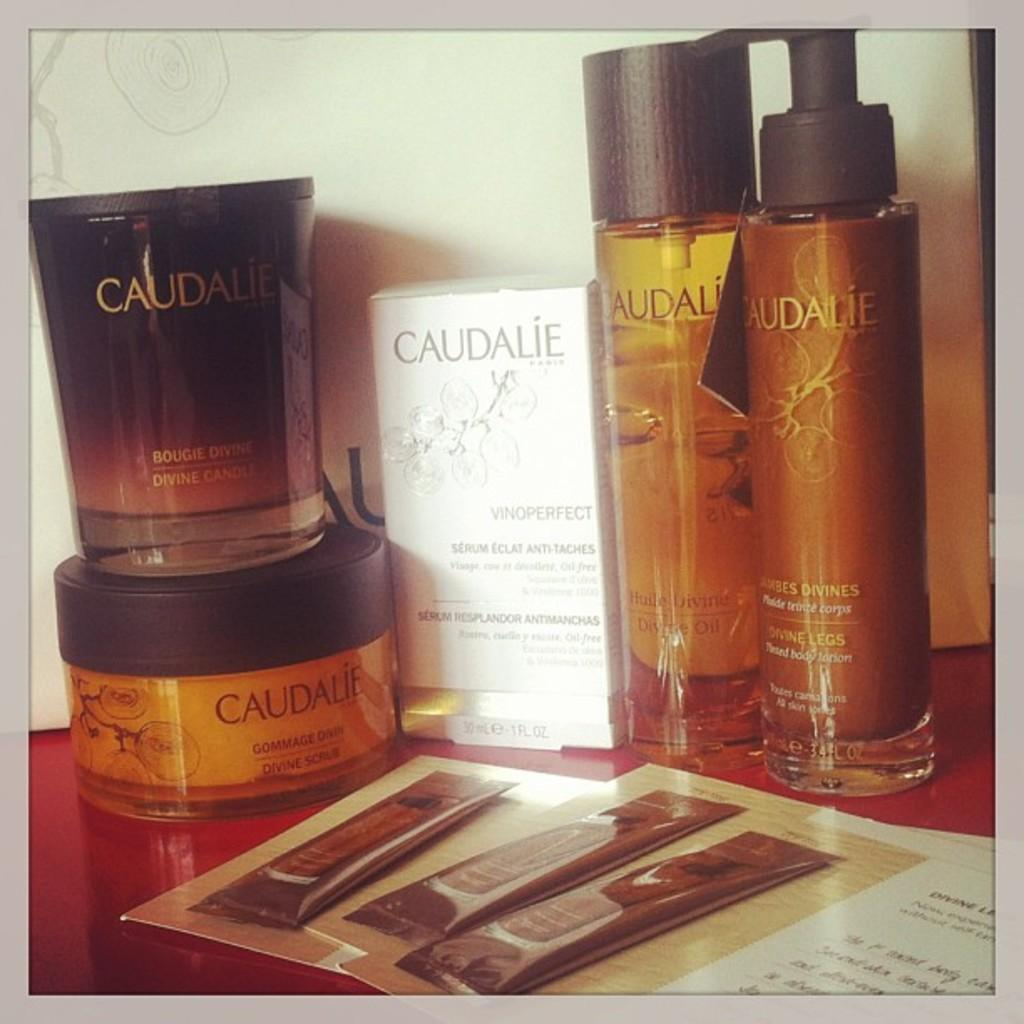<image>
Relay a brief, clear account of the picture shown. Caudalie branded bottles and containers are on display. 